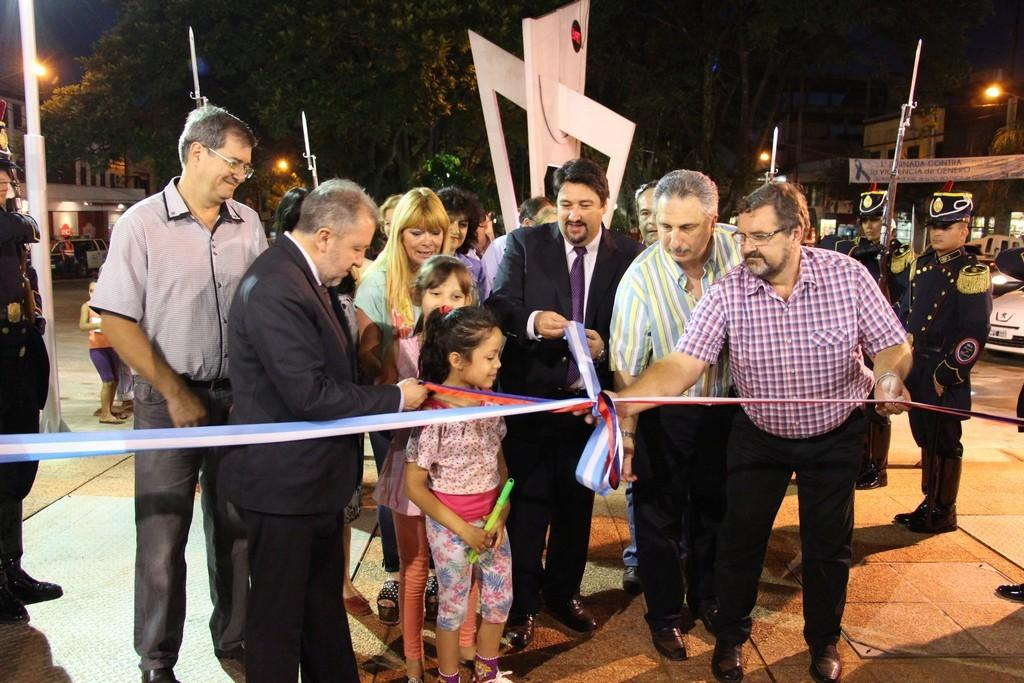How many people are in the image? There is a group of people in the image, but the exact number cannot be determined from the provided facts. What can be seen in the background of the image? There are trees and at least one building in the background of the image. What is the source of illumination in the image? Lights are visible in the image. What type of pets are visible in the image? There are no pets present in the image. Can you tell me which lawyer is representing the group of people in the image? There is no mention of a lawyer or any legal representation in the image. 